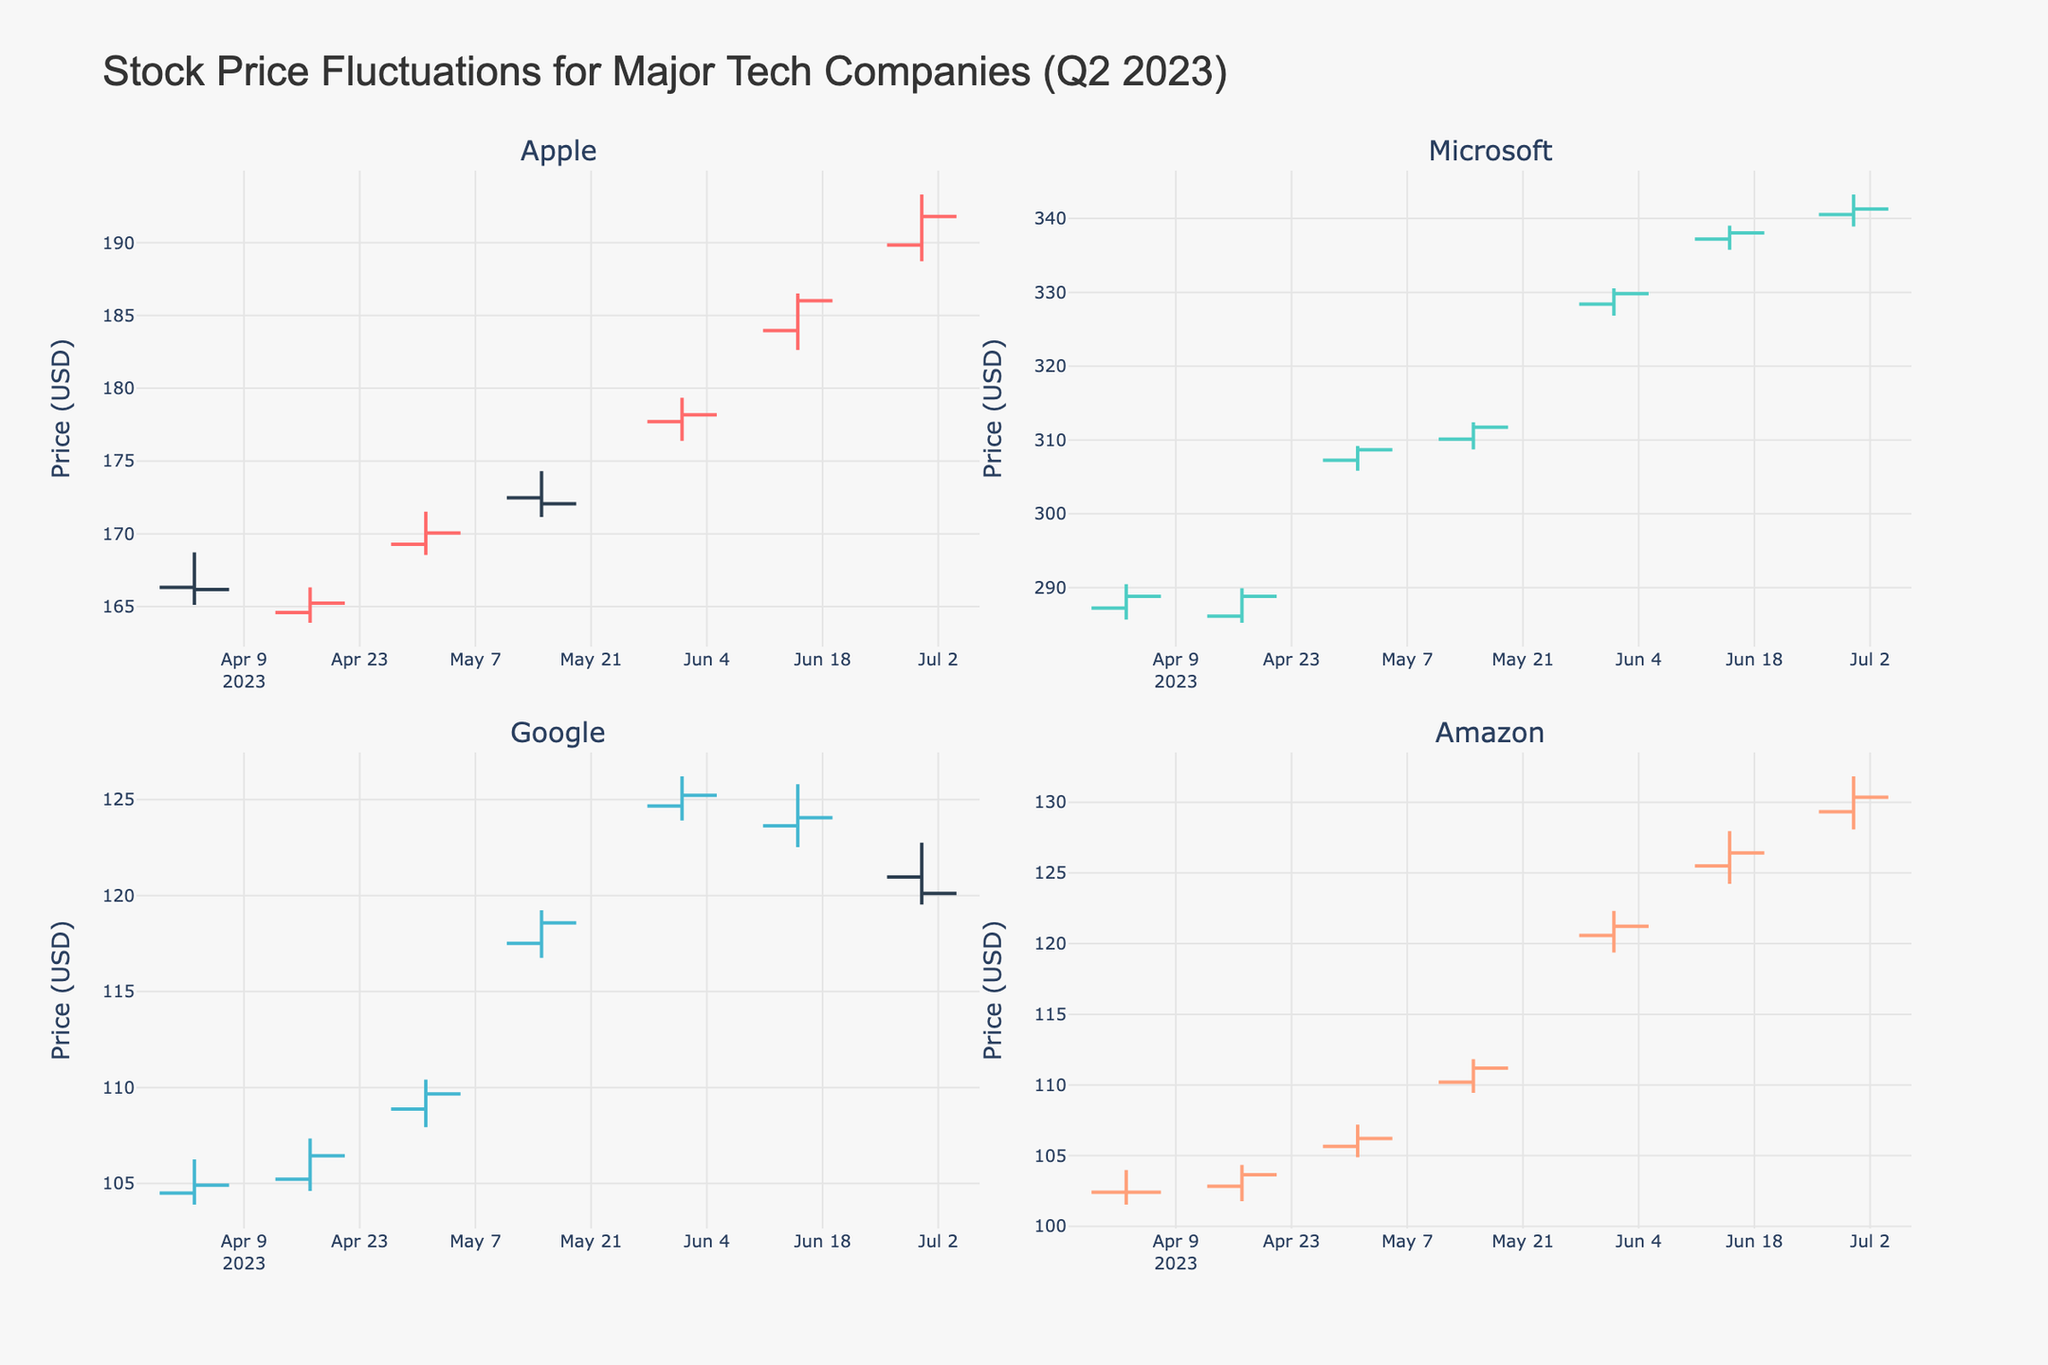What is the title of the chart? The title is displayed prominently at the top of the figure. It reads "Stock Price Fluctuations for Major Tech Companies (Q2 2023)".
Answer: Stock Price Fluctuations for Major Tech Companies (Q2 2023) How many companies are displayed in the chart? The chart has four subplots, each depicting a different company. The companies are Apple, Microsoft, Google, and Amazon.
Answer: Four Which company experienced the highest closing price in June? The closing prices for June are the final values in each company's subplot. Apple closes at 191.81, Microsoft at 341.27, Google at 120.11, and Amazon at 130.36. Among these, Microsoft has the highest closing price.
Answer: Microsoft On which date did Amazon have its highest closing price? By examining the subplot for Amazon, the highest closing price recorded for Amazon is 130.36 on June 30.
Answer: June 30 What was the biggest price drop between any two consecutive dates for Apple? Analyze the closing prices for Apple between consecutive dates: 166.17 to 165.23 (0.94 drop), 165.23 to 170.06 (4.83 increase), 170.06 to 172.07 (2.01 increase), 172.07 to 178.18 (6.11 increase), 178.18 to 186.01 (7.83 increase), 186.01 to 191.81 (5.80 increase). The biggest increase is from 170.06 to 172.07, so no major drop is observed indicating consecutive price growth. The drop is 0.94 from 166.17 to 165.23.
Answer: 0.94 How does the closing price of Microsoft on June 01 compare to that on June 30? For Microsoft, the subplot shows the closing price on June 01 is 329.81, and on June 30 it is 341.27. To compare, 329.81 is less than 341.27 indicating an increase.
Answer: It increased Which company had a decrease in closing price on June 30 compared to June 15? The companies to be examined are Apple, Microsoft, Google, and Amazon. The closing prices on June 15 and June 30 are:
- Apple: 186.01 to 191.81 (increase)
- Microsoft: 338.05 to 341.27 (increase)
- Google: 124.06 to 120.11 (decrease)
- Amazon: 126.42 to 130.36 (increase)
The company with a closing price decrease is Google.
Answer: Google Which company had the smallest range between its high and low prices on June 15? To determine the range between high and low prices for each company on June 15:
- Apple: 186.52 - 182.63 = 3.89
- Microsoft: 339.04 - 335.77 = 3.27
- Google: 125.80 - 122.53 = 3.27
- Amazon: 127.96 - 124.23 = 3.73
Comparing these ranges, the smallest is 3.27 for Microsoft and Google, so it is shared.
Answer: Microsoft and Google 